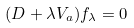<formula> <loc_0><loc_0><loc_500><loc_500>( D + \lambda V _ { a } ) f _ { \lambda } = 0</formula> 